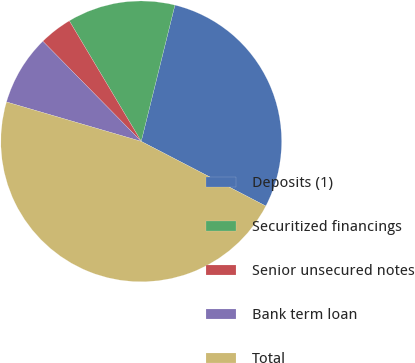Convert chart to OTSL. <chart><loc_0><loc_0><loc_500><loc_500><pie_chart><fcel>Deposits (1)<fcel>Securitized financings<fcel>Senior unsecured notes<fcel>Bank term loan<fcel>Total<nl><fcel>28.76%<fcel>12.42%<fcel>3.8%<fcel>8.11%<fcel>46.91%<nl></chart> 